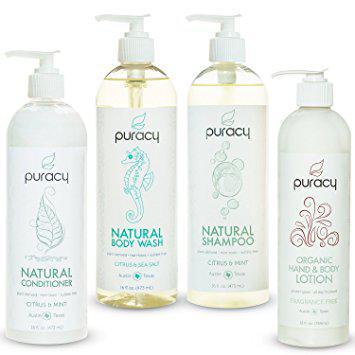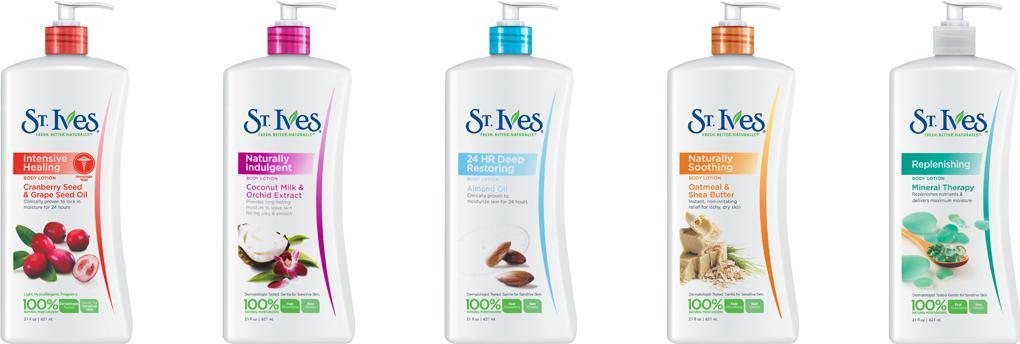The first image is the image on the left, the second image is the image on the right. Examine the images to the left and right. Is the description "One image includes an upright bottle with a black pump-top near a tube displayed upright sitting on its white cap." accurate? Answer yes or no. No. The first image is the image on the left, the second image is the image on the right. For the images displayed, is the sentence "There are more items in the right image than in the left image." factually correct? Answer yes or no. Yes. 